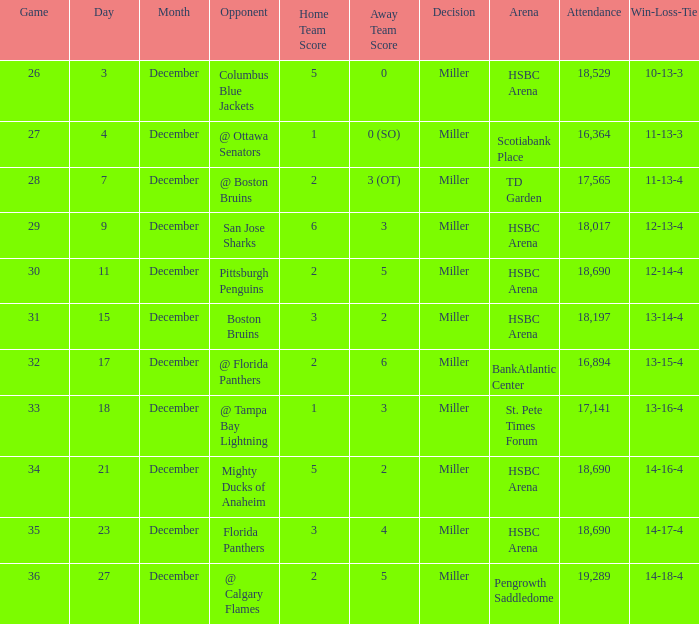Name the score for 29 game 6-3. Can you give me this table as a dict? {'header': ['Game', 'Day', 'Month', 'Opponent', 'Home Team Score', 'Away Team Score', 'Decision', 'Arena', 'Attendance', 'Win-Loss-Tie'], 'rows': [['26', '3', 'December', 'Columbus Blue Jackets', '5', '0', 'Miller', 'HSBC Arena', '18,529', '10-13-3'], ['27', '4', 'December', '@ Ottawa Senators', '1', '0 (SO)', 'Miller', 'Scotiabank Place', '16,364', '11-13-3'], ['28', '7', 'December', '@ Boston Bruins', '2', '3 (OT)', 'Miller', 'TD Garden', '17,565', '11-13-4'], ['29', '9', 'December', 'San Jose Sharks', '6', '3', 'Miller', 'HSBC Arena', '18,017', '12-13-4'], ['30', '11', 'December', 'Pittsburgh Penguins', '2', '5', 'Miller', 'HSBC Arena', '18,690', '12-14-4'], ['31', '15', 'December', 'Boston Bruins', '3', '2', 'Miller', 'HSBC Arena', '18,197', '13-14-4'], ['32', '17', 'December', '@ Florida Panthers', '2', '6', 'Miller', 'BankAtlantic Center', '16,894', '13-15-4'], ['33', '18', 'December', '@ Tampa Bay Lightning', '1', '3', 'Miller', 'St. Pete Times Forum', '17,141', '13-16-4'], ['34', '21', 'December', 'Mighty Ducks of Anaheim', '5', '2', 'Miller', 'HSBC Arena', '18,690', '14-16-4'], ['35', '23', 'December', 'Florida Panthers', '3', '4', 'Miller', 'HSBC Arena', '18,690', '14-17-4'], ['36', '27', 'December', '@ Calgary Flames', '2', '5', 'Miller', 'Pengrowth Saddledome', '19,289', '14-18-4']]} 